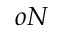<formula> <loc_0><loc_0><loc_500><loc_500>o N</formula> 